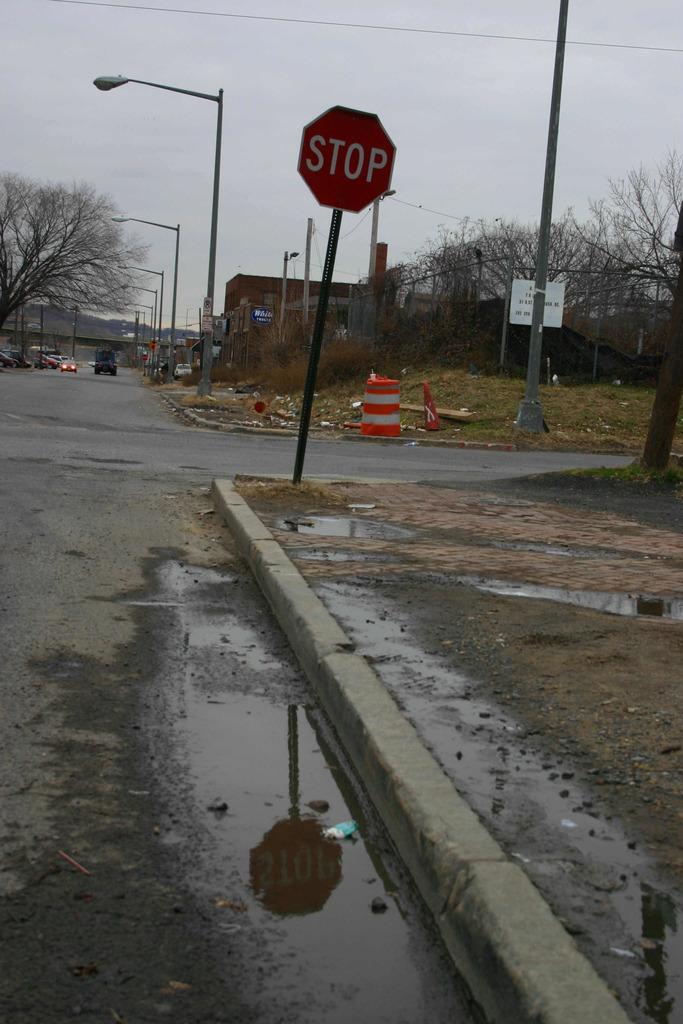What does the sign say?
Give a very brief answer. Stop. 